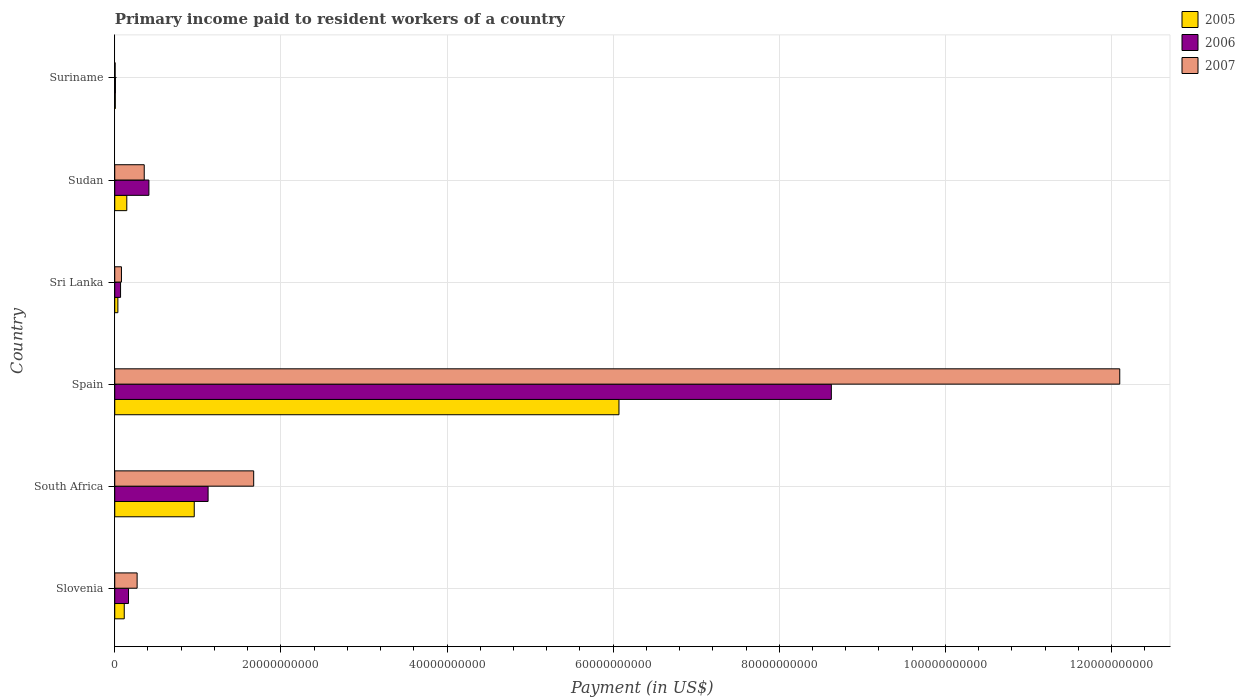How many different coloured bars are there?
Give a very brief answer. 3. Are the number of bars on each tick of the Y-axis equal?
Your answer should be compact. Yes. How many bars are there on the 4th tick from the top?
Offer a terse response. 3. What is the label of the 2nd group of bars from the top?
Keep it short and to the point. Sudan. In how many cases, is the number of bars for a given country not equal to the number of legend labels?
Give a very brief answer. 0. What is the amount paid to workers in 2006 in South Africa?
Keep it short and to the point. 1.12e+1. Across all countries, what is the maximum amount paid to workers in 2007?
Provide a succinct answer. 1.21e+11. Across all countries, what is the minimum amount paid to workers in 2007?
Your response must be concise. 4.62e+07. In which country was the amount paid to workers in 2005 minimum?
Provide a succinct answer. Suriname. What is the total amount paid to workers in 2006 in the graph?
Offer a very short reply. 1.04e+11. What is the difference between the amount paid to workers in 2006 in Sri Lanka and that in Sudan?
Give a very brief answer. -3.41e+09. What is the difference between the amount paid to workers in 2006 in South Africa and the amount paid to workers in 2005 in Suriname?
Your answer should be compact. 1.12e+1. What is the average amount paid to workers in 2005 per country?
Offer a terse response. 1.22e+1. What is the difference between the amount paid to workers in 2005 and amount paid to workers in 2006 in South Africa?
Make the answer very short. -1.67e+09. In how many countries, is the amount paid to workers in 2006 greater than 108000000000 US$?
Provide a succinct answer. 0. What is the ratio of the amount paid to workers in 2006 in Spain to that in Suriname?
Keep it short and to the point. 1085.11. Is the difference between the amount paid to workers in 2005 in Sri Lanka and Suriname greater than the difference between the amount paid to workers in 2006 in Sri Lanka and Suriname?
Offer a terse response. No. What is the difference between the highest and the second highest amount paid to workers in 2005?
Give a very brief answer. 5.11e+1. What is the difference between the highest and the lowest amount paid to workers in 2005?
Offer a terse response. 6.06e+1. What does the 3rd bar from the top in Suriname represents?
Your answer should be compact. 2005. How many bars are there?
Keep it short and to the point. 18. Are all the bars in the graph horizontal?
Your answer should be very brief. Yes. How many countries are there in the graph?
Ensure brevity in your answer.  6. How many legend labels are there?
Provide a short and direct response. 3. What is the title of the graph?
Ensure brevity in your answer.  Primary income paid to resident workers of a country. What is the label or title of the X-axis?
Offer a very short reply. Payment (in US$). What is the label or title of the Y-axis?
Your answer should be very brief. Country. What is the Payment (in US$) in 2005 in Slovenia?
Your answer should be compact. 1.14e+09. What is the Payment (in US$) in 2006 in Slovenia?
Your answer should be very brief. 1.66e+09. What is the Payment (in US$) in 2007 in Slovenia?
Your response must be concise. 2.69e+09. What is the Payment (in US$) in 2005 in South Africa?
Offer a terse response. 9.57e+09. What is the Payment (in US$) of 2006 in South Africa?
Your response must be concise. 1.12e+1. What is the Payment (in US$) in 2007 in South Africa?
Offer a very short reply. 1.67e+1. What is the Payment (in US$) in 2005 in Spain?
Give a very brief answer. 6.07e+1. What is the Payment (in US$) of 2006 in Spain?
Your answer should be compact. 8.63e+1. What is the Payment (in US$) of 2007 in Spain?
Provide a short and direct response. 1.21e+11. What is the Payment (in US$) of 2005 in Sri Lanka?
Your answer should be very brief. 3.75e+08. What is the Payment (in US$) of 2006 in Sri Lanka?
Offer a very short reply. 7.00e+08. What is the Payment (in US$) of 2007 in Sri Lanka?
Make the answer very short. 8.07e+08. What is the Payment (in US$) of 2005 in Sudan?
Your answer should be compact. 1.45e+09. What is the Payment (in US$) in 2006 in Sudan?
Your answer should be compact. 4.11e+09. What is the Payment (in US$) in 2007 in Sudan?
Keep it short and to the point. 3.55e+09. What is the Payment (in US$) in 2005 in Suriname?
Ensure brevity in your answer.  6.44e+07. What is the Payment (in US$) in 2006 in Suriname?
Offer a very short reply. 7.95e+07. What is the Payment (in US$) of 2007 in Suriname?
Offer a terse response. 4.62e+07. Across all countries, what is the maximum Payment (in US$) of 2005?
Provide a succinct answer. 6.07e+1. Across all countries, what is the maximum Payment (in US$) of 2006?
Offer a very short reply. 8.63e+1. Across all countries, what is the maximum Payment (in US$) of 2007?
Keep it short and to the point. 1.21e+11. Across all countries, what is the minimum Payment (in US$) in 2005?
Your answer should be very brief. 6.44e+07. Across all countries, what is the minimum Payment (in US$) of 2006?
Your answer should be very brief. 7.95e+07. Across all countries, what is the minimum Payment (in US$) in 2007?
Offer a terse response. 4.62e+07. What is the total Payment (in US$) of 2005 in the graph?
Provide a short and direct response. 7.33e+1. What is the total Payment (in US$) of 2006 in the graph?
Ensure brevity in your answer.  1.04e+11. What is the total Payment (in US$) in 2007 in the graph?
Your response must be concise. 1.45e+11. What is the difference between the Payment (in US$) of 2005 in Slovenia and that in South Africa?
Offer a terse response. -8.43e+09. What is the difference between the Payment (in US$) in 2006 in Slovenia and that in South Africa?
Your answer should be compact. -9.58e+09. What is the difference between the Payment (in US$) of 2007 in Slovenia and that in South Africa?
Your answer should be very brief. -1.40e+1. What is the difference between the Payment (in US$) of 2005 in Slovenia and that in Spain?
Offer a terse response. -5.96e+1. What is the difference between the Payment (in US$) of 2006 in Slovenia and that in Spain?
Your answer should be compact. -8.46e+1. What is the difference between the Payment (in US$) in 2007 in Slovenia and that in Spain?
Your answer should be very brief. -1.18e+11. What is the difference between the Payment (in US$) of 2005 in Slovenia and that in Sri Lanka?
Make the answer very short. 7.68e+08. What is the difference between the Payment (in US$) in 2006 in Slovenia and that in Sri Lanka?
Make the answer very short. 9.56e+08. What is the difference between the Payment (in US$) in 2007 in Slovenia and that in Sri Lanka?
Keep it short and to the point. 1.89e+09. What is the difference between the Payment (in US$) of 2005 in Slovenia and that in Sudan?
Make the answer very short. -3.06e+08. What is the difference between the Payment (in US$) in 2006 in Slovenia and that in Sudan?
Offer a very short reply. -2.45e+09. What is the difference between the Payment (in US$) of 2007 in Slovenia and that in Sudan?
Make the answer very short. -8.55e+08. What is the difference between the Payment (in US$) of 2005 in Slovenia and that in Suriname?
Offer a terse response. 1.08e+09. What is the difference between the Payment (in US$) in 2006 in Slovenia and that in Suriname?
Your answer should be very brief. 1.58e+09. What is the difference between the Payment (in US$) in 2007 in Slovenia and that in Suriname?
Offer a very short reply. 2.65e+09. What is the difference between the Payment (in US$) in 2005 in South Africa and that in Spain?
Your answer should be very brief. -5.11e+1. What is the difference between the Payment (in US$) of 2006 in South Africa and that in Spain?
Provide a succinct answer. -7.50e+1. What is the difference between the Payment (in US$) of 2007 in South Africa and that in Spain?
Provide a succinct answer. -1.04e+11. What is the difference between the Payment (in US$) in 2005 in South Africa and that in Sri Lanka?
Ensure brevity in your answer.  9.19e+09. What is the difference between the Payment (in US$) in 2006 in South Africa and that in Sri Lanka?
Provide a succinct answer. 1.05e+1. What is the difference between the Payment (in US$) in 2007 in South Africa and that in Sri Lanka?
Keep it short and to the point. 1.59e+1. What is the difference between the Payment (in US$) of 2005 in South Africa and that in Sudan?
Offer a terse response. 8.12e+09. What is the difference between the Payment (in US$) in 2006 in South Africa and that in Sudan?
Your response must be concise. 7.13e+09. What is the difference between the Payment (in US$) in 2007 in South Africa and that in Sudan?
Give a very brief answer. 1.32e+1. What is the difference between the Payment (in US$) of 2005 in South Africa and that in Suriname?
Your response must be concise. 9.50e+09. What is the difference between the Payment (in US$) in 2006 in South Africa and that in Suriname?
Make the answer very short. 1.12e+1. What is the difference between the Payment (in US$) of 2007 in South Africa and that in Suriname?
Give a very brief answer. 1.67e+1. What is the difference between the Payment (in US$) in 2005 in Spain and that in Sri Lanka?
Ensure brevity in your answer.  6.03e+1. What is the difference between the Payment (in US$) of 2006 in Spain and that in Sri Lanka?
Your answer should be compact. 8.56e+1. What is the difference between the Payment (in US$) in 2007 in Spain and that in Sri Lanka?
Provide a short and direct response. 1.20e+11. What is the difference between the Payment (in US$) of 2005 in Spain and that in Sudan?
Offer a terse response. 5.93e+1. What is the difference between the Payment (in US$) of 2006 in Spain and that in Sudan?
Your response must be concise. 8.22e+1. What is the difference between the Payment (in US$) in 2007 in Spain and that in Sudan?
Ensure brevity in your answer.  1.17e+11. What is the difference between the Payment (in US$) in 2005 in Spain and that in Suriname?
Your answer should be very brief. 6.06e+1. What is the difference between the Payment (in US$) of 2006 in Spain and that in Suriname?
Offer a terse response. 8.62e+1. What is the difference between the Payment (in US$) in 2007 in Spain and that in Suriname?
Provide a short and direct response. 1.21e+11. What is the difference between the Payment (in US$) of 2005 in Sri Lanka and that in Sudan?
Ensure brevity in your answer.  -1.07e+09. What is the difference between the Payment (in US$) of 2006 in Sri Lanka and that in Sudan?
Make the answer very short. -3.41e+09. What is the difference between the Payment (in US$) in 2007 in Sri Lanka and that in Sudan?
Offer a very short reply. -2.74e+09. What is the difference between the Payment (in US$) of 2005 in Sri Lanka and that in Suriname?
Your answer should be very brief. 3.11e+08. What is the difference between the Payment (in US$) in 2006 in Sri Lanka and that in Suriname?
Make the answer very short. 6.20e+08. What is the difference between the Payment (in US$) of 2007 in Sri Lanka and that in Suriname?
Provide a short and direct response. 7.61e+08. What is the difference between the Payment (in US$) of 2005 in Sudan and that in Suriname?
Provide a succinct answer. 1.39e+09. What is the difference between the Payment (in US$) in 2006 in Sudan and that in Suriname?
Offer a terse response. 4.03e+09. What is the difference between the Payment (in US$) in 2007 in Sudan and that in Suriname?
Make the answer very short. 3.50e+09. What is the difference between the Payment (in US$) of 2005 in Slovenia and the Payment (in US$) of 2006 in South Africa?
Make the answer very short. -1.01e+1. What is the difference between the Payment (in US$) of 2005 in Slovenia and the Payment (in US$) of 2007 in South Africa?
Your response must be concise. -1.56e+1. What is the difference between the Payment (in US$) in 2006 in Slovenia and the Payment (in US$) in 2007 in South Africa?
Keep it short and to the point. -1.51e+1. What is the difference between the Payment (in US$) in 2005 in Slovenia and the Payment (in US$) in 2006 in Spain?
Your answer should be compact. -8.51e+1. What is the difference between the Payment (in US$) of 2005 in Slovenia and the Payment (in US$) of 2007 in Spain?
Your response must be concise. -1.20e+11. What is the difference between the Payment (in US$) of 2006 in Slovenia and the Payment (in US$) of 2007 in Spain?
Give a very brief answer. -1.19e+11. What is the difference between the Payment (in US$) of 2005 in Slovenia and the Payment (in US$) of 2006 in Sri Lanka?
Your answer should be compact. 4.43e+08. What is the difference between the Payment (in US$) of 2005 in Slovenia and the Payment (in US$) of 2007 in Sri Lanka?
Your answer should be compact. 3.37e+08. What is the difference between the Payment (in US$) of 2006 in Slovenia and the Payment (in US$) of 2007 in Sri Lanka?
Provide a succinct answer. 8.50e+08. What is the difference between the Payment (in US$) in 2005 in Slovenia and the Payment (in US$) in 2006 in Sudan?
Your response must be concise. -2.97e+09. What is the difference between the Payment (in US$) in 2005 in Slovenia and the Payment (in US$) in 2007 in Sudan?
Keep it short and to the point. -2.40e+09. What is the difference between the Payment (in US$) of 2006 in Slovenia and the Payment (in US$) of 2007 in Sudan?
Offer a very short reply. -1.89e+09. What is the difference between the Payment (in US$) in 2005 in Slovenia and the Payment (in US$) in 2006 in Suriname?
Offer a terse response. 1.06e+09. What is the difference between the Payment (in US$) in 2005 in Slovenia and the Payment (in US$) in 2007 in Suriname?
Ensure brevity in your answer.  1.10e+09. What is the difference between the Payment (in US$) of 2006 in Slovenia and the Payment (in US$) of 2007 in Suriname?
Your answer should be very brief. 1.61e+09. What is the difference between the Payment (in US$) in 2005 in South Africa and the Payment (in US$) in 2006 in Spain?
Make the answer very short. -7.67e+1. What is the difference between the Payment (in US$) of 2005 in South Africa and the Payment (in US$) of 2007 in Spain?
Your response must be concise. -1.11e+11. What is the difference between the Payment (in US$) of 2006 in South Africa and the Payment (in US$) of 2007 in Spain?
Make the answer very short. -1.10e+11. What is the difference between the Payment (in US$) of 2005 in South Africa and the Payment (in US$) of 2006 in Sri Lanka?
Your answer should be compact. 8.87e+09. What is the difference between the Payment (in US$) in 2005 in South Africa and the Payment (in US$) in 2007 in Sri Lanka?
Offer a very short reply. 8.76e+09. What is the difference between the Payment (in US$) of 2006 in South Africa and the Payment (in US$) of 2007 in Sri Lanka?
Make the answer very short. 1.04e+1. What is the difference between the Payment (in US$) in 2005 in South Africa and the Payment (in US$) in 2006 in Sudan?
Your response must be concise. 5.46e+09. What is the difference between the Payment (in US$) in 2005 in South Africa and the Payment (in US$) in 2007 in Sudan?
Make the answer very short. 6.02e+09. What is the difference between the Payment (in US$) in 2006 in South Africa and the Payment (in US$) in 2007 in Sudan?
Make the answer very short. 7.69e+09. What is the difference between the Payment (in US$) of 2005 in South Africa and the Payment (in US$) of 2006 in Suriname?
Offer a terse response. 9.49e+09. What is the difference between the Payment (in US$) of 2005 in South Africa and the Payment (in US$) of 2007 in Suriname?
Offer a terse response. 9.52e+09. What is the difference between the Payment (in US$) in 2006 in South Africa and the Payment (in US$) in 2007 in Suriname?
Provide a short and direct response. 1.12e+1. What is the difference between the Payment (in US$) of 2005 in Spain and the Payment (in US$) of 2006 in Sri Lanka?
Ensure brevity in your answer.  6.00e+1. What is the difference between the Payment (in US$) of 2005 in Spain and the Payment (in US$) of 2007 in Sri Lanka?
Provide a succinct answer. 5.99e+1. What is the difference between the Payment (in US$) in 2006 in Spain and the Payment (in US$) in 2007 in Sri Lanka?
Give a very brief answer. 8.55e+1. What is the difference between the Payment (in US$) of 2005 in Spain and the Payment (in US$) of 2006 in Sudan?
Make the answer very short. 5.66e+1. What is the difference between the Payment (in US$) of 2005 in Spain and the Payment (in US$) of 2007 in Sudan?
Offer a very short reply. 5.72e+1. What is the difference between the Payment (in US$) of 2006 in Spain and the Payment (in US$) of 2007 in Sudan?
Make the answer very short. 8.27e+1. What is the difference between the Payment (in US$) in 2005 in Spain and the Payment (in US$) in 2006 in Suriname?
Make the answer very short. 6.06e+1. What is the difference between the Payment (in US$) in 2005 in Spain and the Payment (in US$) in 2007 in Suriname?
Keep it short and to the point. 6.07e+1. What is the difference between the Payment (in US$) in 2006 in Spain and the Payment (in US$) in 2007 in Suriname?
Your answer should be very brief. 8.62e+1. What is the difference between the Payment (in US$) in 2005 in Sri Lanka and the Payment (in US$) in 2006 in Sudan?
Provide a short and direct response. -3.74e+09. What is the difference between the Payment (in US$) of 2005 in Sri Lanka and the Payment (in US$) of 2007 in Sudan?
Offer a very short reply. -3.17e+09. What is the difference between the Payment (in US$) in 2006 in Sri Lanka and the Payment (in US$) in 2007 in Sudan?
Your response must be concise. -2.85e+09. What is the difference between the Payment (in US$) in 2005 in Sri Lanka and the Payment (in US$) in 2006 in Suriname?
Provide a succinct answer. 2.96e+08. What is the difference between the Payment (in US$) in 2005 in Sri Lanka and the Payment (in US$) in 2007 in Suriname?
Your response must be concise. 3.29e+08. What is the difference between the Payment (in US$) in 2006 in Sri Lanka and the Payment (in US$) in 2007 in Suriname?
Your answer should be compact. 6.54e+08. What is the difference between the Payment (in US$) of 2005 in Sudan and the Payment (in US$) of 2006 in Suriname?
Offer a terse response. 1.37e+09. What is the difference between the Payment (in US$) of 2005 in Sudan and the Payment (in US$) of 2007 in Suriname?
Your answer should be very brief. 1.40e+09. What is the difference between the Payment (in US$) in 2006 in Sudan and the Payment (in US$) in 2007 in Suriname?
Ensure brevity in your answer.  4.06e+09. What is the average Payment (in US$) of 2005 per country?
Your answer should be very brief. 1.22e+1. What is the average Payment (in US$) of 2006 per country?
Make the answer very short. 1.73e+1. What is the average Payment (in US$) of 2007 per country?
Offer a very short reply. 2.41e+1. What is the difference between the Payment (in US$) in 2005 and Payment (in US$) in 2006 in Slovenia?
Make the answer very short. -5.13e+08. What is the difference between the Payment (in US$) in 2005 and Payment (in US$) in 2007 in Slovenia?
Keep it short and to the point. -1.55e+09. What is the difference between the Payment (in US$) in 2006 and Payment (in US$) in 2007 in Slovenia?
Provide a succinct answer. -1.04e+09. What is the difference between the Payment (in US$) in 2005 and Payment (in US$) in 2006 in South Africa?
Offer a very short reply. -1.67e+09. What is the difference between the Payment (in US$) of 2005 and Payment (in US$) of 2007 in South Africa?
Offer a terse response. -7.16e+09. What is the difference between the Payment (in US$) of 2006 and Payment (in US$) of 2007 in South Africa?
Keep it short and to the point. -5.49e+09. What is the difference between the Payment (in US$) in 2005 and Payment (in US$) in 2006 in Spain?
Make the answer very short. -2.56e+1. What is the difference between the Payment (in US$) in 2005 and Payment (in US$) in 2007 in Spain?
Keep it short and to the point. -6.03e+1. What is the difference between the Payment (in US$) of 2006 and Payment (in US$) of 2007 in Spain?
Provide a succinct answer. -3.47e+1. What is the difference between the Payment (in US$) of 2005 and Payment (in US$) of 2006 in Sri Lanka?
Your answer should be compact. -3.25e+08. What is the difference between the Payment (in US$) of 2005 and Payment (in US$) of 2007 in Sri Lanka?
Offer a terse response. -4.31e+08. What is the difference between the Payment (in US$) in 2006 and Payment (in US$) in 2007 in Sri Lanka?
Offer a very short reply. -1.07e+08. What is the difference between the Payment (in US$) in 2005 and Payment (in US$) in 2006 in Sudan?
Your answer should be compact. -2.66e+09. What is the difference between the Payment (in US$) in 2005 and Payment (in US$) in 2007 in Sudan?
Offer a terse response. -2.10e+09. What is the difference between the Payment (in US$) of 2006 and Payment (in US$) of 2007 in Sudan?
Your answer should be very brief. 5.63e+08. What is the difference between the Payment (in US$) in 2005 and Payment (in US$) in 2006 in Suriname?
Ensure brevity in your answer.  -1.51e+07. What is the difference between the Payment (in US$) in 2005 and Payment (in US$) in 2007 in Suriname?
Offer a terse response. 1.82e+07. What is the difference between the Payment (in US$) of 2006 and Payment (in US$) of 2007 in Suriname?
Provide a short and direct response. 3.33e+07. What is the ratio of the Payment (in US$) of 2005 in Slovenia to that in South Africa?
Offer a terse response. 0.12. What is the ratio of the Payment (in US$) of 2006 in Slovenia to that in South Africa?
Ensure brevity in your answer.  0.15. What is the ratio of the Payment (in US$) in 2007 in Slovenia to that in South Africa?
Your response must be concise. 0.16. What is the ratio of the Payment (in US$) of 2005 in Slovenia to that in Spain?
Ensure brevity in your answer.  0.02. What is the ratio of the Payment (in US$) in 2006 in Slovenia to that in Spain?
Your response must be concise. 0.02. What is the ratio of the Payment (in US$) in 2007 in Slovenia to that in Spain?
Provide a succinct answer. 0.02. What is the ratio of the Payment (in US$) of 2005 in Slovenia to that in Sri Lanka?
Provide a short and direct response. 3.05. What is the ratio of the Payment (in US$) in 2006 in Slovenia to that in Sri Lanka?
Your answer should be compact. 2.37. What is the ratio of the Payment (in US$) of 2007 in Slovenia to that in Sri Lanka?
Provide a short and direct response. 3.34. What is the ratio of the Payment (in US$) in 2005 in Slovenia to that in Sudan?
Ensure brevity in your answer.  0.79. What is the ratio of the Payment (in US$) of 2006 in Slovenia to that in Sudan?
Provide a short and direct response. 0.4. What is the ratio of the Payment (in US$) of 2007 in Slovenia to that in Sudan?
Provide a short and direct response. 0.76. What is the ratio of the Payment (in US$) of 2005 in Slovenia to that in Suriname?
Your response must be concise. 17.75. What is the ratio of the Payment (in US$) of 2006 in Slovenia to that in Suriname?
Ensure brevity in your answer.  20.84. What is the ratio of the Payment (in US$) in 2007 in Slovenia to that in Suriname?
Provide a succinct answer. 58.3. What is the ratio of the Payment (in US$) of 2005 in South Africa to that in Spain?
Offer a terse response. 0.16. What is the ratio of the Payment (in US$) of 2006 in South Africa to that in Spain?
Provide a short and direct response. 0.13. What is the ratio of the Payment (in US$) in 2007 in South Africa to that in Spain?
Ensure brevity in your answer.  0.14. What is the ratio of the Payment (in US$) of 2005 in South Africa to that in Sri Lanka?
Your answer should be very brief. 25.49. What is the ratio of the Payment (in US$) in 2006 in South Africa to that in Sri Lanka?
Give a very brief answer. 16.05. What is the ratio of the Payment (in US$) in 2007 in South Africa to that in Sri Lanka?
Keep it short and to the point. 20.73. What is the ratio of the Payment (in US$) in 2005 in South Africa to that in Sudan?
Offer a terse response. 6.6. What is the ratio of the Payment (in US$) in 2006 in South Africa to that in Sudan?
Ensure brevity in your answer.  2.73. What is the ratio of the Payment (in US$) of 2007 in South Africa to that in Sudan?
Your response must be concise. 4.71. What is the ratio of the Payment (in US$) of 2005 in South Africa to that in Suriname?
Your answer should be very brief. 148.59. What is the ratio of the Payment (in US$) in 2006 in South Africa to that in Suriname?
Ensure brevity in your answer.  141.34. What is the ratio of the Payment (in US$) in 2007 in South Africa to that in Suriname?
Your answer should be compact. 362.02. What is the ratio of the Payment (in US$) of 2005 in Spain to that in Sri Lanka?
Your response must be concise. 161.7. What is the ratio of the Payment (in US$) of 2006 in Spain to that in Sri Lanka?
Your answer should be compact. 123.24. What is the ratio of the Payment (in US$) in 2007 in Spain to that in Sri Lanka?
Provide a succinct answer. 149.94. What is the ratio of the Payment (in US$) of 2005 in Spain to that in Sudan?
Ensure brevity in your answer.  41.87. What is the ratio of the Payment (in US$) in 2006 in Spain to that in Sudan?
Your response must be concise. 20.98. What is the ratio of the Payment (in US$) in 2007 in Spain to that in Sudan?
Make the answer very short. 34.1. What is the ratio of the Payment (in US$) in 2005 in Spain to that in Suriname?
Make the answer very short. 942.56. What is the ratio of the Payment (in US$) of 2006 in Spain to that in Suriname?
Your answer should be very brief. 1085.11. What is the ratio of the Payment (in US$) of 2007 in Spain to that in Suriname?
Provide a short and direct response. 2618.74. What is the ratio of the Payment (in US$) of 2005 in Sri Lanka to that in Sudan?
Offer a terse response. 0.26. What is the ratio of the Payment (in US$) of 2006 in Sri Lanka to that in Sudan?
Your answer should be compact. 0.17. What is the ratio of the Payment (in US$) in 2007 in Sri Lanka to that in Sudan?
Give a very brief answer. 0.23. What is the ratio of the Payment (in US$) of 2005 in Sri Lanka to that in Suriname?
Ensure brevity in your answer.  5.83. What is the ratio of the Payment (in US$) in 2006 in Sri Lanka to that in Suriname?
Your answer should be very brief. 8.8. What is the ratio of the Payment (in US$) of 2007 in Sri Lanka to that in Suriname?
Your answer should be very brief. 17.46. What is the ratio of the Payment (in US$) of 2005 in Sudan to that in Suriname?
Give a very brief answer. 22.51. What is the ratio of the Payment (in US$) in 2006 in Sudan to that in Suriname?
Your answer should be compact. 51.71. What is the ratio of the Payment (in US$) in 2007 in Sudan to that in Suriname?
Your response must be concise. 76.8. What is the difference between the highest and the second highest Payment (in US$) in 2005?
Your answer should be compact. 5.11e+1. What is the difference between the highest and the second highest Payment (in US$) in 2006?
Your answer should be very brief. 7.50e+1. What is the difference between the highest and the second highest Payment (in US$) of 2007?
Offer a terse response. 1.04e+11. What is the difference between the highest and the lowest Payment (in US$) in 2005?
Make the answer very short. 6.06e+1. What is the difference between the highest and the lowest Payment (in US$) of 2006?
Provide a succinct answer. 8.62e+1. What is the difference between the highest and the lowest Payment (in US$) of 2007?
Ensure brevity in your answer.  1.21e+11. 